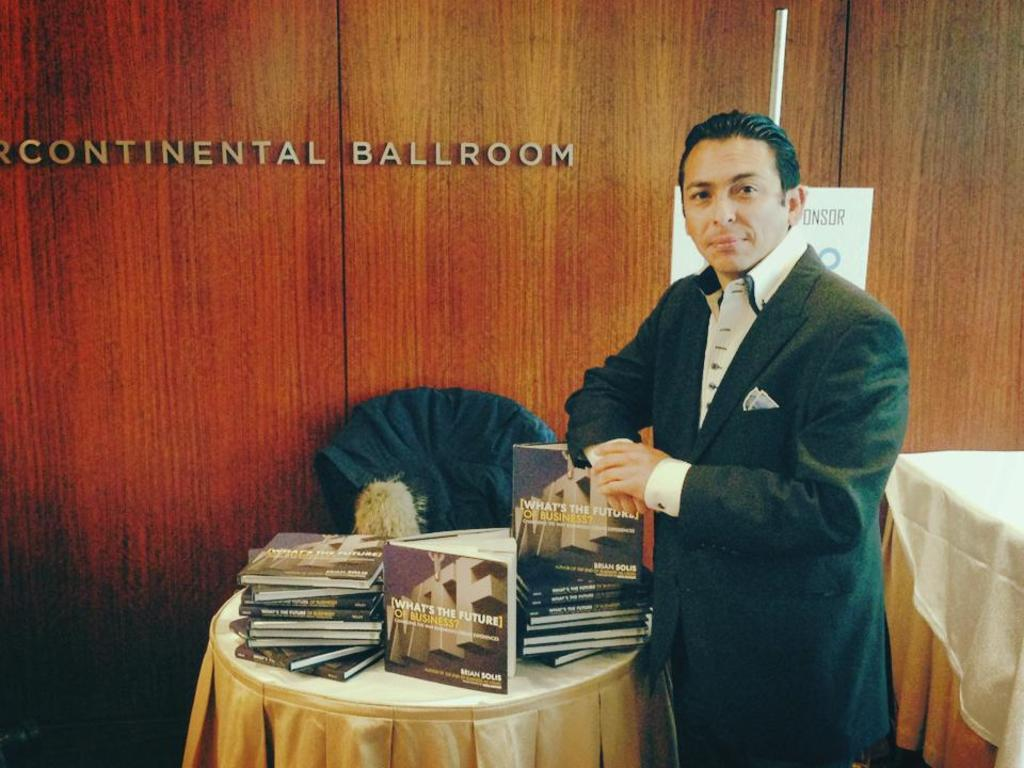<image>
Create a compact narrative representing the image presented. A man standing next to a pile of books in the continental ballroom. 